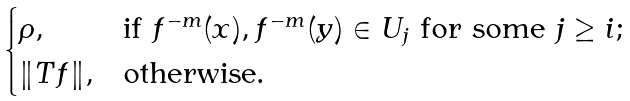<formula> <loc_0><loc_0><loc_500><loc_500>\begin{cases} \rho , & \text {if $f^{-m}(x), f^{-m}(y)\in U_{j}$ for some $j\geq i$;} \\ \| T f \| , & \text {otherwise.} \\ \end{cases}</formula> 